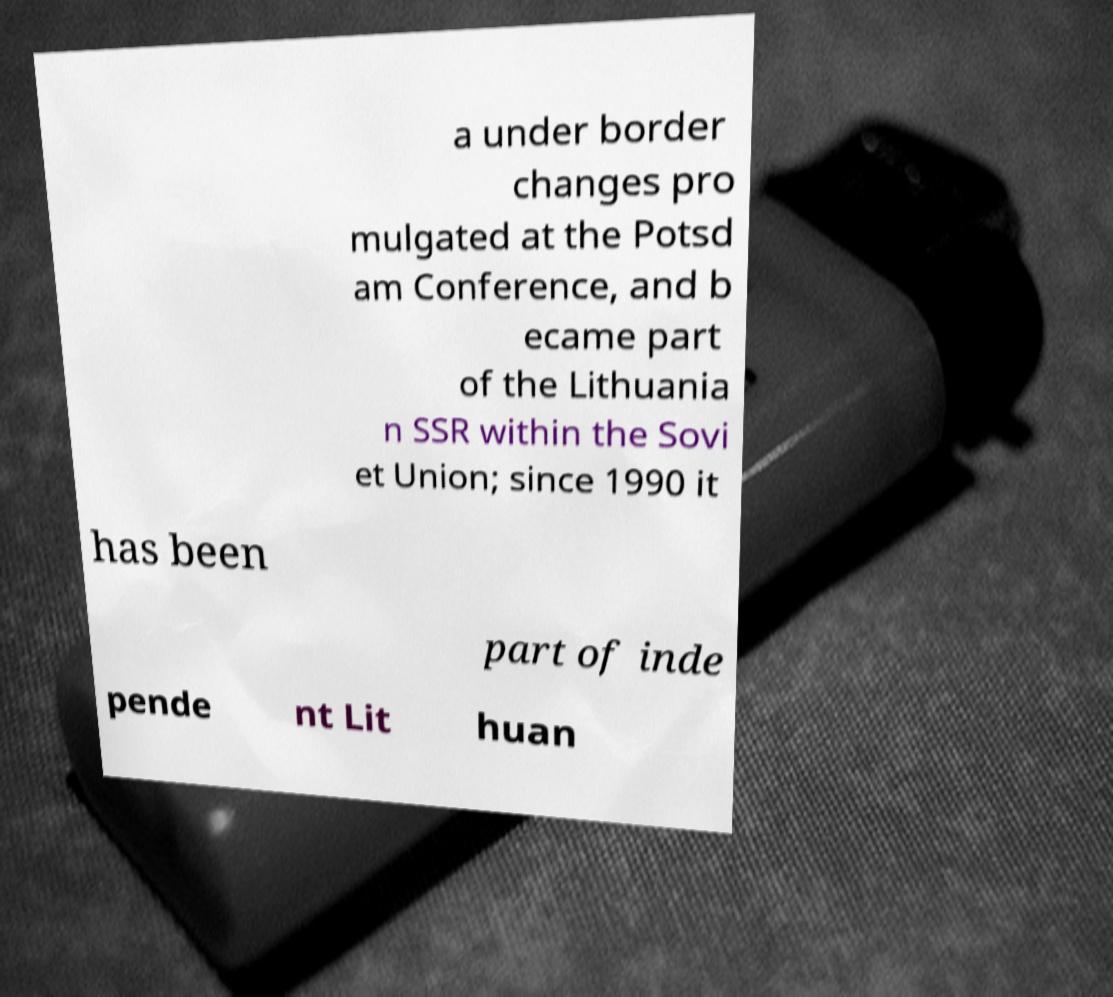Please identify and transcribe the text found in this image. a under border changes pro mulgated at the Potsd am Conference, and b ecame part of the Lithuania n SSR within the Sovi et Union; since 1990 it has been part of inde pende nt Lit huan 